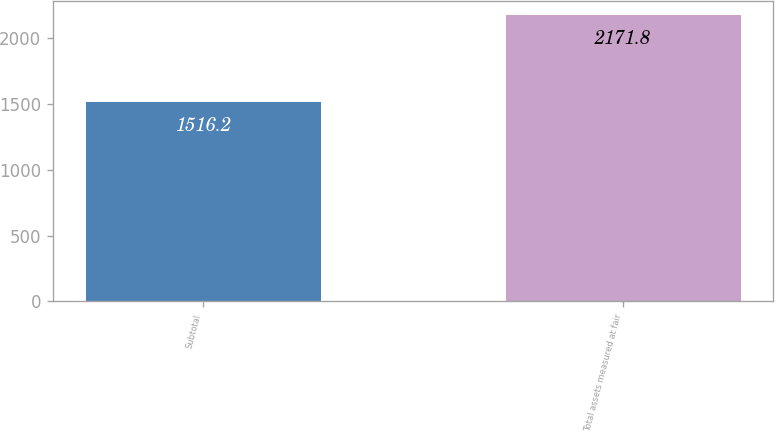Convert chart to OTSL. <chart><loc_0><loc_0><loc_500><loc_500><bar_chart><fcel>Subtotal<fcel>Total assets measured at fair<nl><fcel>1516.2<fcel>2171.8<nl></chart> 